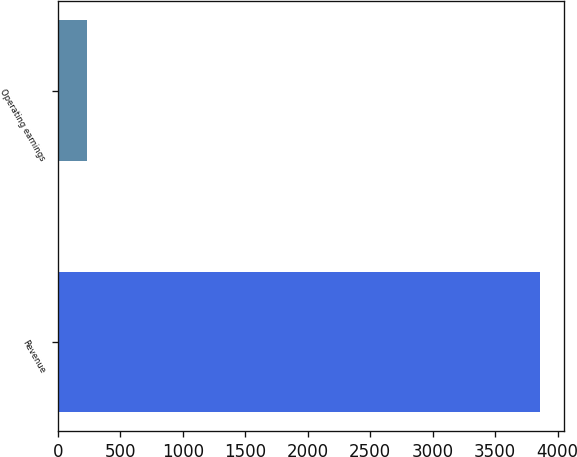<chart> <loc_0><loc_0><loc_500><loc_500><bar_chart><fcel>Revenue<fcel>Operating earnings<nl><fcel>3859<fcel>235<nl></chart> 